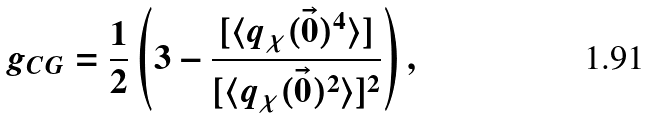<formula> <loc_0><loc_0><loc_500><loc_500>g _ { C G } = \frac { 1 } { 2 } \left ( 3 - \frac { [ \langle q _ { \chi } ( \vec { 0 } ) ^ { 4 } \rangle ] } { [ \langle q _ { \chi } ( \vec { 0 } ) ^ { 2 } \rangle ] ^ { 2 } } \right ) ,</formula> 